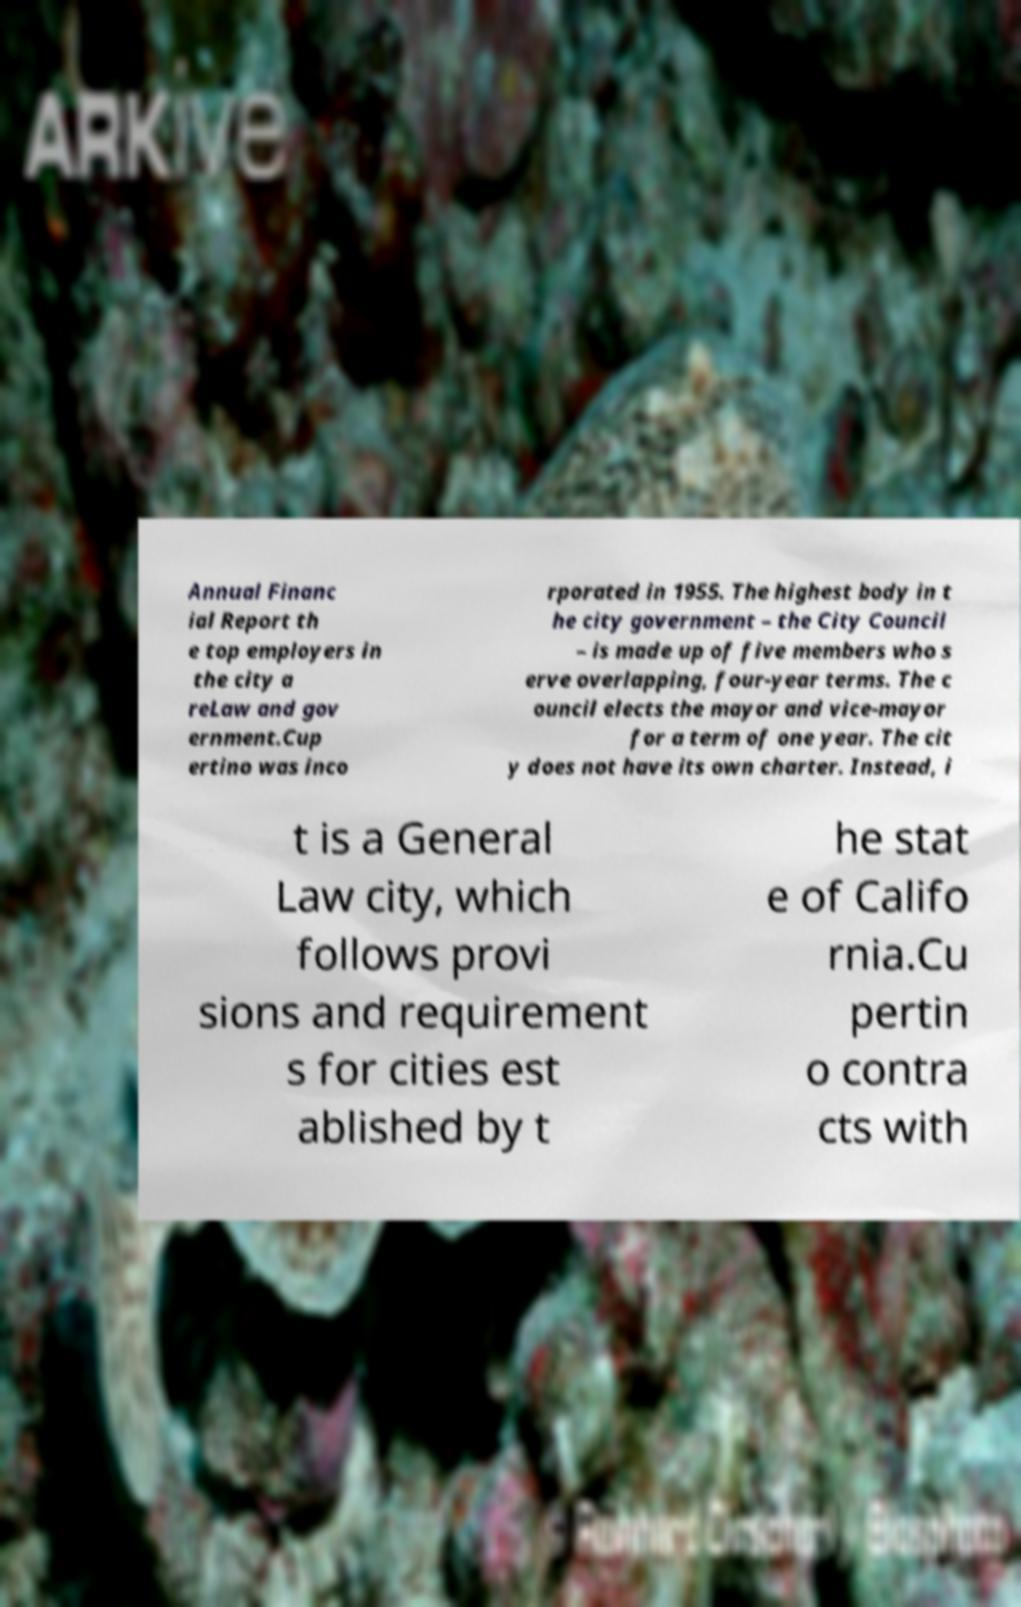Could you extract and type out the text from this image? Annual Financ ial Report th e top employers in the city a reLaw and gov ernment.Cup ertino was inco rporated in 1955. The highest body in t he city government – the City Council – is made up of five members who s erve overlapping, four-year terms. The c ouncil elects the mayor and vice-mayor for a term of one year. The cit y does not have its own charter. Instead, i t is a General Law city, which follows provi sions and requirement s for cities est ablished by t he stat e of Califo rnia.Cu pertin o contra cts with 